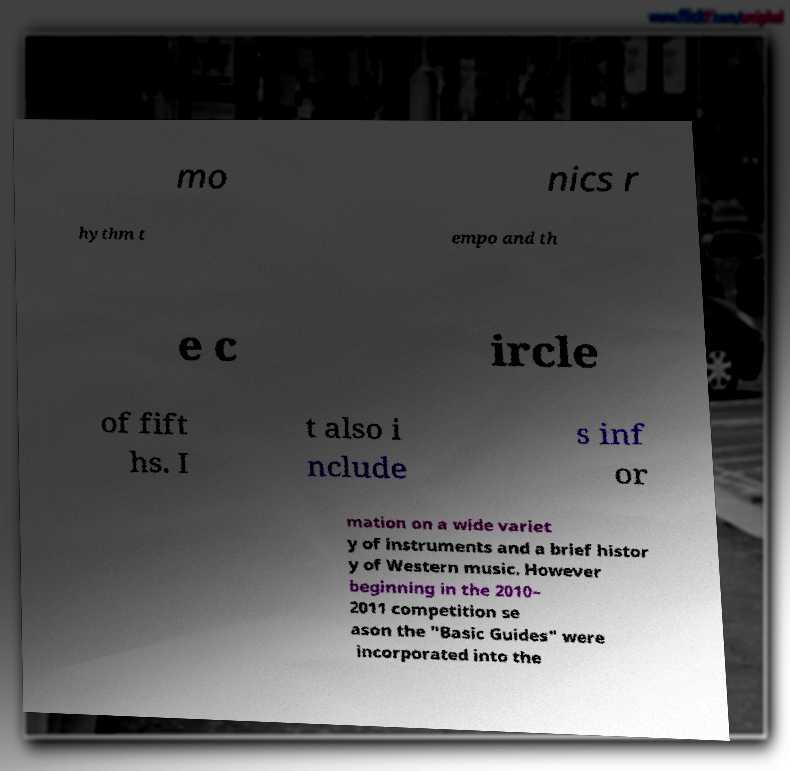Please read and relay the text visible in this image. What does it say? mo nics r hythm t empo and th e c ircle of fift hs. I t also i nclude s inf or mation on a wide variet y of instruments and a brief histor y of Western music. However beginning in the 2010– 2011 competition se ason the "Basic Guides" were incorporated into the 